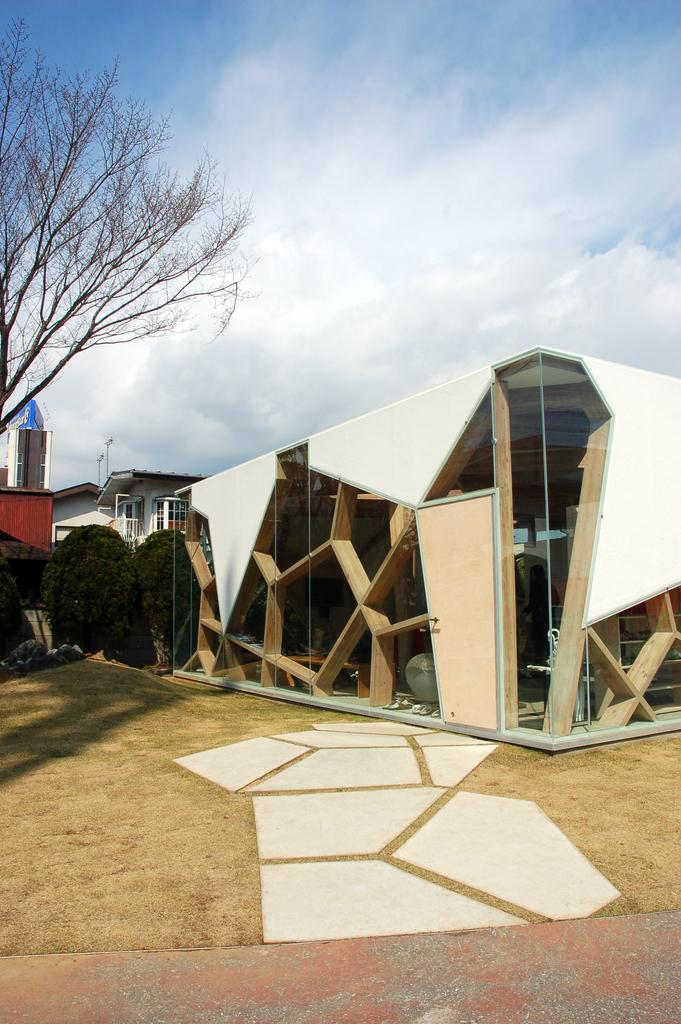What is located in the foreground of the image? There is a shed and trees in the foreground of the image. What is visible in the background of the image? There is a house and poles in the background of the image. What can be seen at the top of the image? The sky is visible at the top of the image. When was the image taken? The image was taken during the day. Can you see a worm crawling on the shed in the image? There is no worm visible in the image; it only features a shed, trees, a house, poles, and the sky. What type of potato is being grown in the background of the image? There are no potatoes present in the image; it only features a shed, trees, a house, poles, and the sky. 